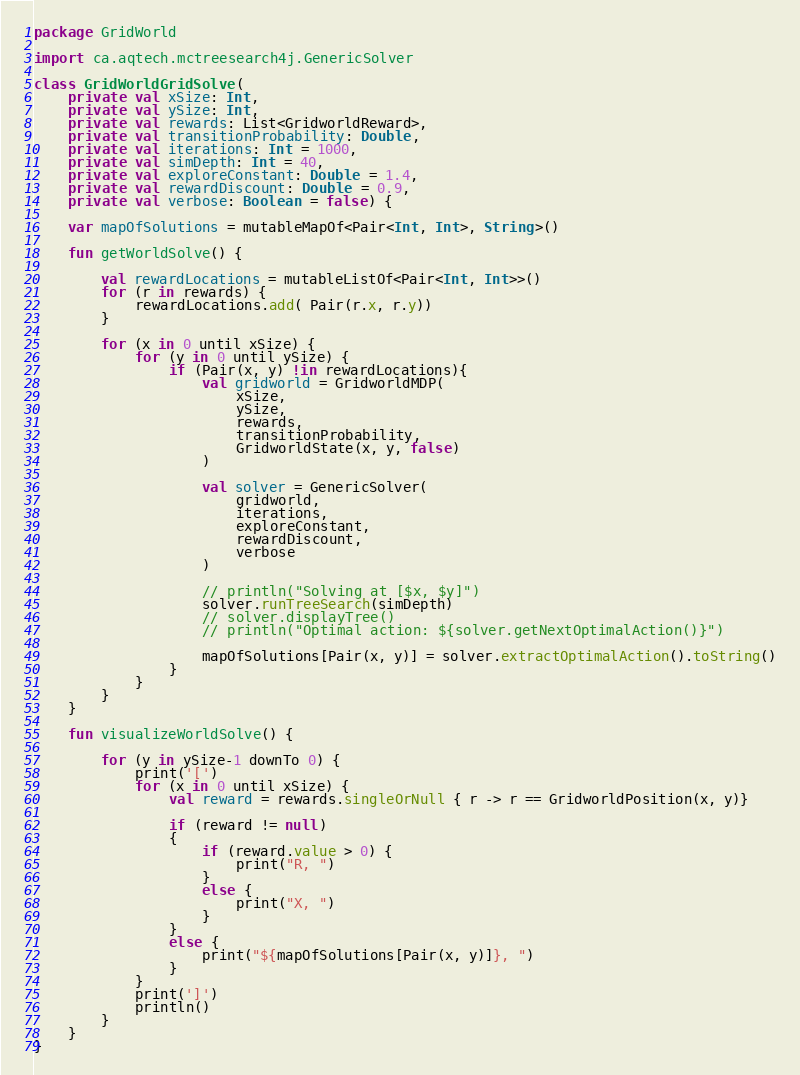Convert code to text. <code><loc_0><loc_0><loc_500><loc_500><_Kotlin_>package GridWorld

import ca.aqtech.mctreesearch4j.GenericSolver

class GridWorldGridSolve(
    private val xSize: Int,
    private val ySize: Int,
    private val rewards: List<GridworldReward>,
    private val transitionProbability: Double,
    private val iterations: Int = 1000,
    private val simDepth: Int = 40,
    private val exploreConstant: Double = 1.4,
    private val rewardDiscount: Double = 0.9,
    private val verbose: Boolean = false) {

    var mapOfSolutions = mutableMapOf<Pair<Int, Int>, String>()

    fun getWorldSolve() {

        val rewardLocations = mutableListOf<Pair<Int, Int>>()
        for (r in rewards) {
            rewardLocations.add( Pair(r.x, r.y))
        }

        for (x in 0 until xSize) {
            for (y in 0 until ySize) {
                if (Pair(x, y) !in rewardLocations){
                    val gridworld = GridworldMDP(
                        xSize,
                        ySize,
                        rewards,
                        transitionProbability,
                        GridworldState(x, y, false)
                    )

                    val solver = GenericSolver(
                        gridworld,
                        iterations,
                        exploreConstant,
                        rewardDiscount,
                        verbose
                    )

                    // println("Solving at [$x, $y]")
                    solver.runTreeSearch(simDepth)
                    // solver.displayTree()
                    // println("Optimal action: ${solver.getNextOptimalAction()}")

                    mapOfSolutions[Pair(x, y)] = solver.extractOptimalAction().toString()
                }
            }
        }
    }

    fun visualizeWorldSolve() {

        for (y in ySize-1 downTo 0) {
            print('[')
            for (x in 0 until xSize) {
                val reward = rewards.singleOrNull { r -> r == GridworldPosition(x, y)}

                if (reward != null)
                {
                    if (reward.value > 0) {
                        print("R, ")
                    }
                    else {
                        print("X, ")
                    }
                }
                else {
                    print("${mapOfSolutions[Pair(x, y)]}, ")
                }
            }
            print(']')
            println()
        }
    }
}</code> 